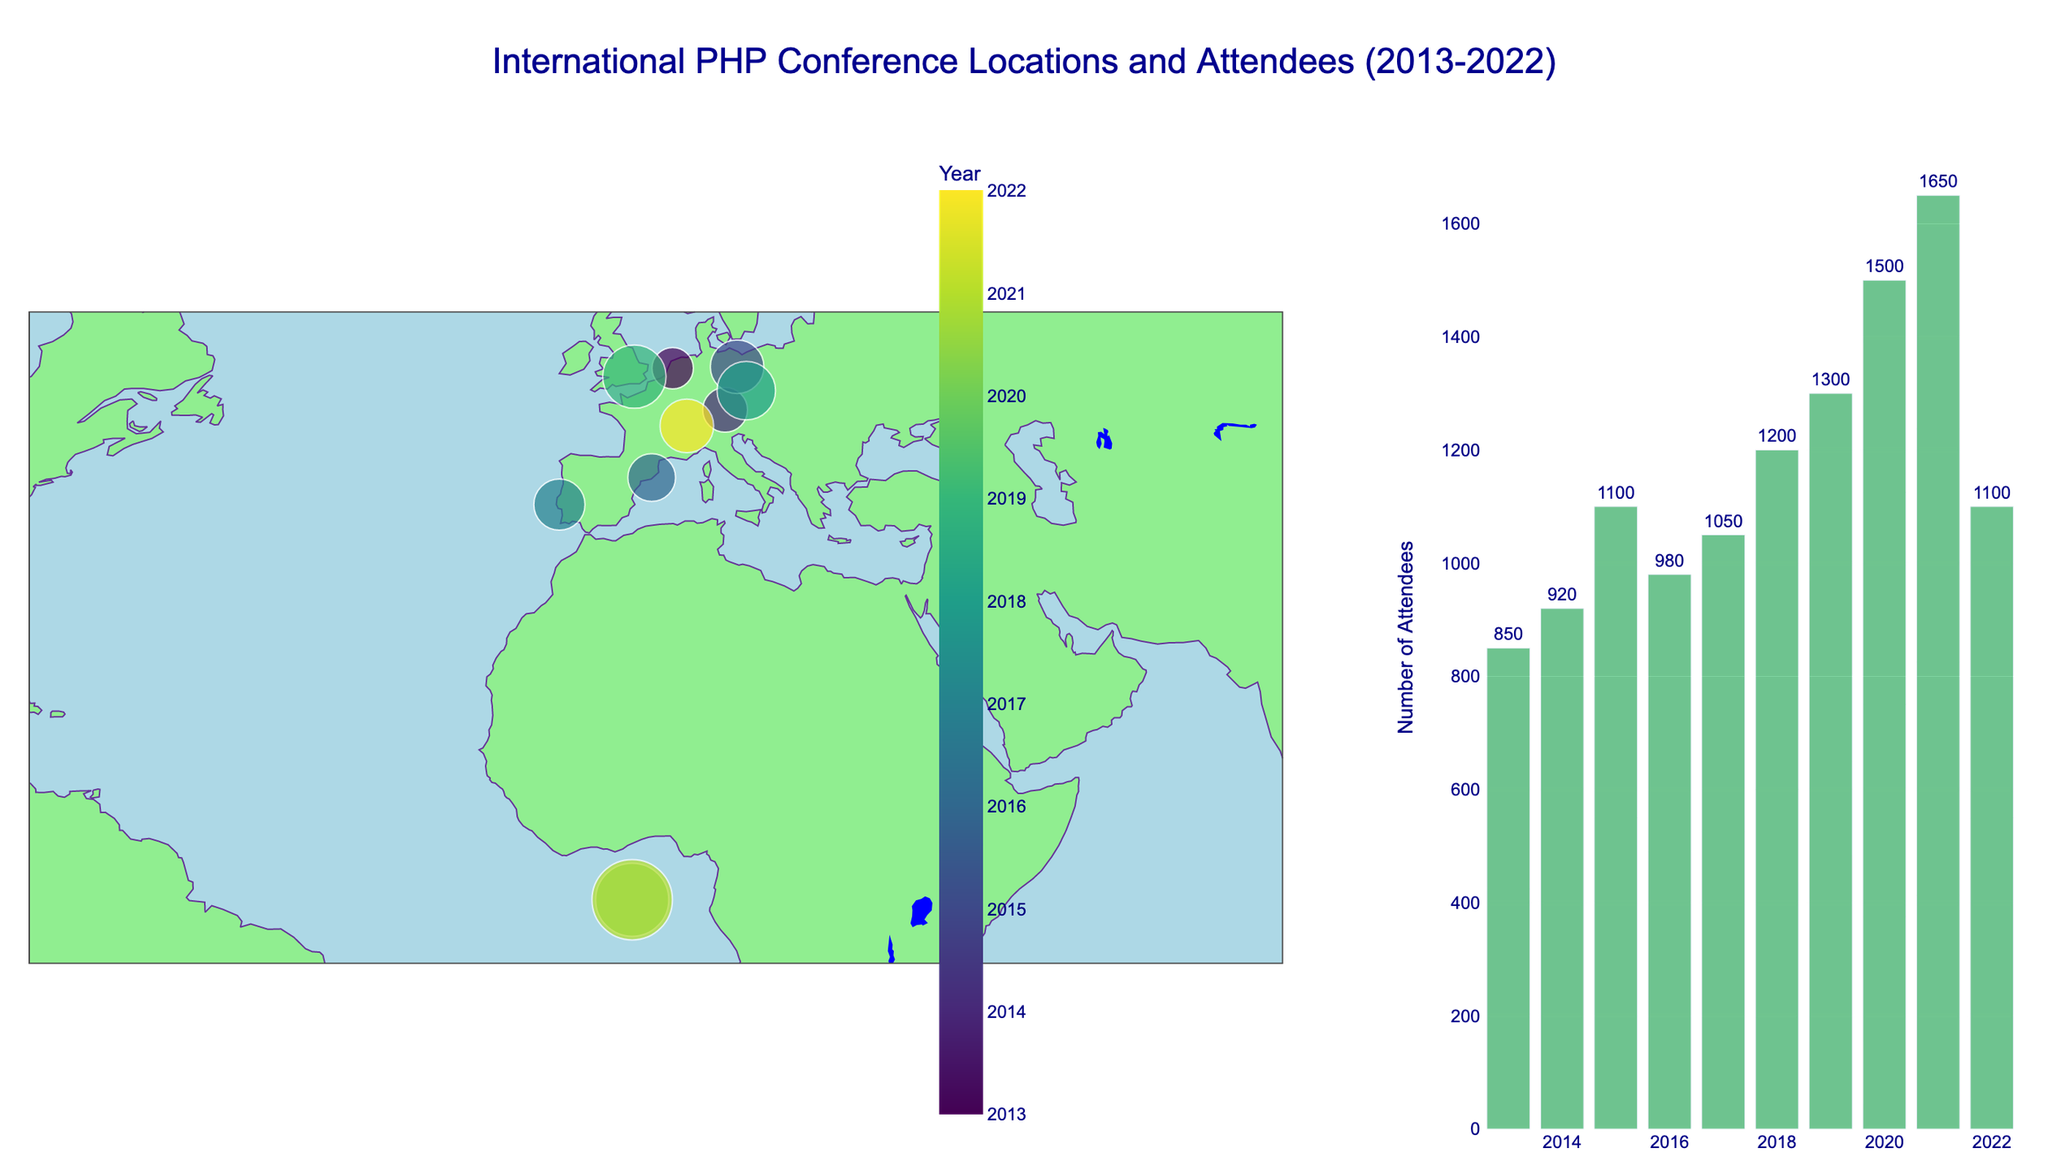what countries have hosted the International PHP Conference? Looking at the map, there are markers in the Netherlands, Germany, Spain, Portugal, Czech Republic, United Kingdom, and Switzerland. We can list these countries.
Answer: Netherlands, Germany, Spain, Portugal, Czech Republic, United Kingdom, Switzerland how many attendees were there in the year with the highest attendance? Checking the bar chart, the year 2021 (Virtual) had the highest attendance with a bar extending the tallest. The number of attendees for this year is marked next to the bar as 1650.
Answer: 1650 which city had the least number of attendees? Looking at the bar chart and comparing the heights of the bars, Amsterdam in 2013 has the smallest bar, indicating the least number of attendees. The attendees are 850.
Answer: Amsterdam which year had the highest percentage of beginner attendees? We can interpret the data associated with the colors and markers on the bar chart. The year 2020 has the highest percentage of beginner attendees at 35%.
Answer: 2020 how many total attendees were there from 2013 to 2019? Sum the number of attendees for each year from 2013 to 2019: 850+920+1100+980+1050+1200+1300 = 7400.
Answer: 7400 how has the number of attendees changed over the decade? Observing the bar chart from left to right, we can see an overall increasing trend in the number of attendees, with a peak in 2021.
Answer: Increasing compare the number of beginner attendees in 2013 and 2022. Calculate 30% of 850 attendees in 2013 and compare it to 30% of 1100 attendees in 2022. For 2013: 0.3 * 850 = 255. For 2022: 0.3 * 1100 = 330. So, 2022 had more beginner attendees.
Answer: 2022 how many more attendees were there in Berlin (2015) compared to Amsterdam (2013)? Find the difference between the attendees: 1100 (Berlin) - 850 (Amsterdam) = 250.
Answer: 250 